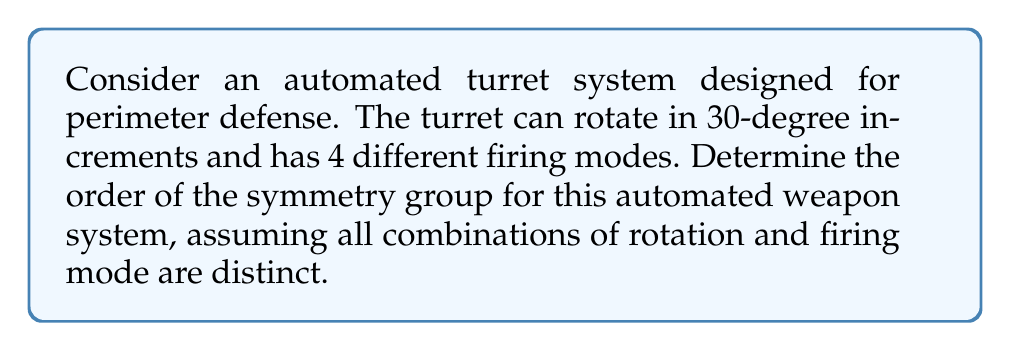Give your solution to this math problem. To solve this problem, we need to consider the following steps:

1) First, let's identify the elements of the symmetry group:
   - Rotations: The turret can rotate in 30-degree increments. This means there are 360°/30° = 12 possible rotations.
   - Firing modes: There are 4 different firing modes.

2) Each element in the symmetry group is a combination of a rotation and a firing mode. Therefore, we need to use the multiplication principle.

3) The number of elements in the symmetry group is:
   $$ |G| = (\text{number of rotations}) \times (\text{number of firing modes}) $$
   $$ |G| = 12 \times 4 $$

4) Calculate the result:
   $$ |G| = 48 $$

5) In group theory, the number of elements in a group is called its order. Therefore, the order of the symmetry group for this automated weapon system is 48.

This result implies that there are 48 distinct states or configurations that the automated turret system can be in, each representing a unique combination of rotation angle and firing mode.
Answer: The order of the symmetry group for the automated weapon system is 48. 